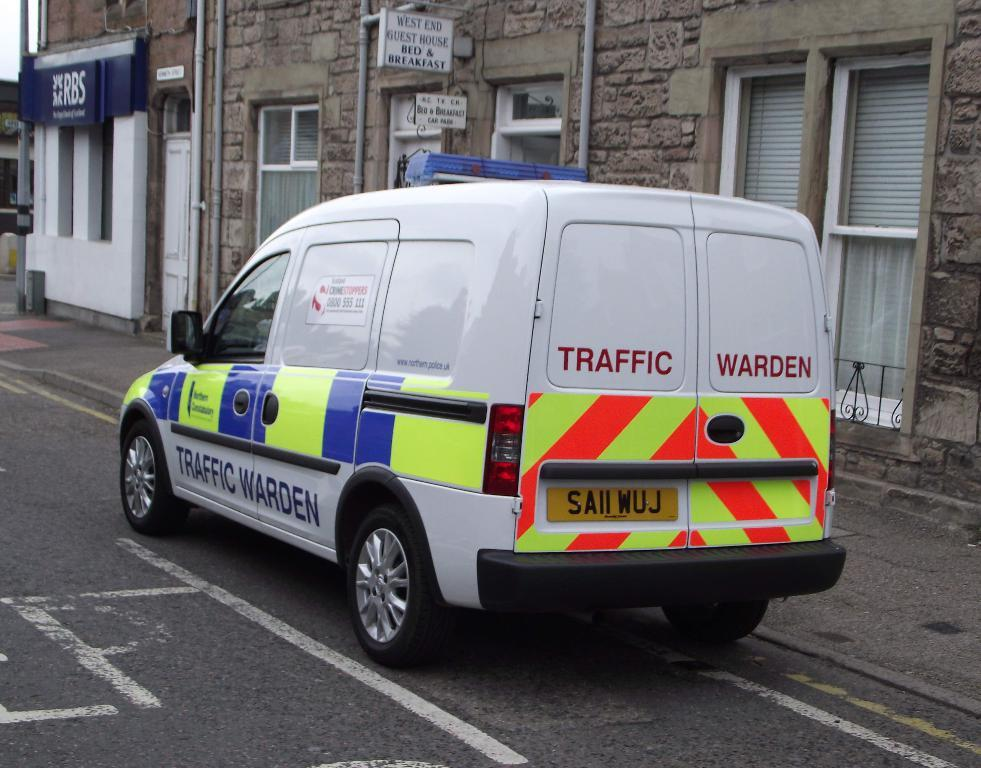Provide a one-sentence caption for the provided image. A traffic warden van is pulled over to the right side of the street. 